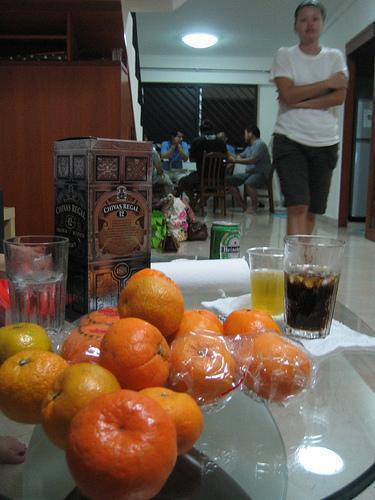The woman is doing what?
From the following four choices, select the correct answer to address the question.
Options: Crossing arms, running, stretching, jumping jacks. Crossing arms. 